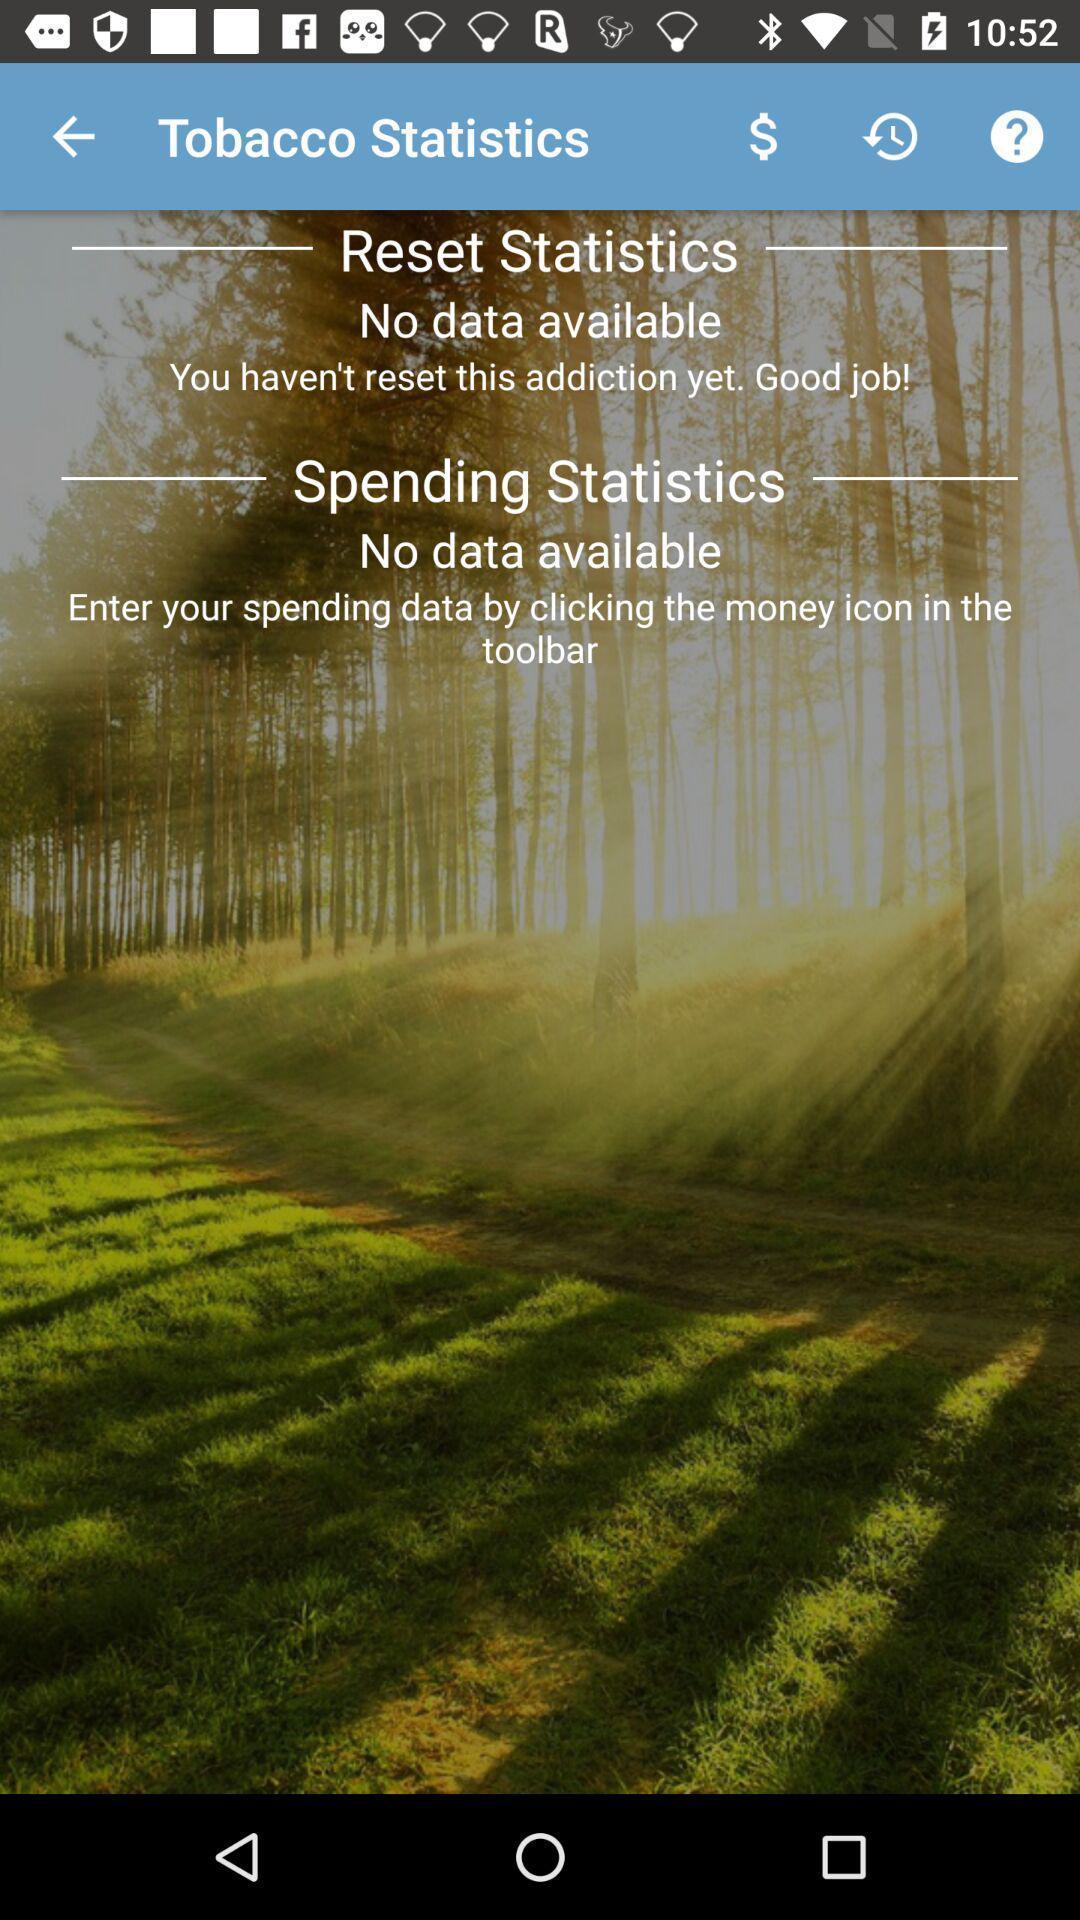What details can you identify in this image? Page displaying the tobacco statistics. 